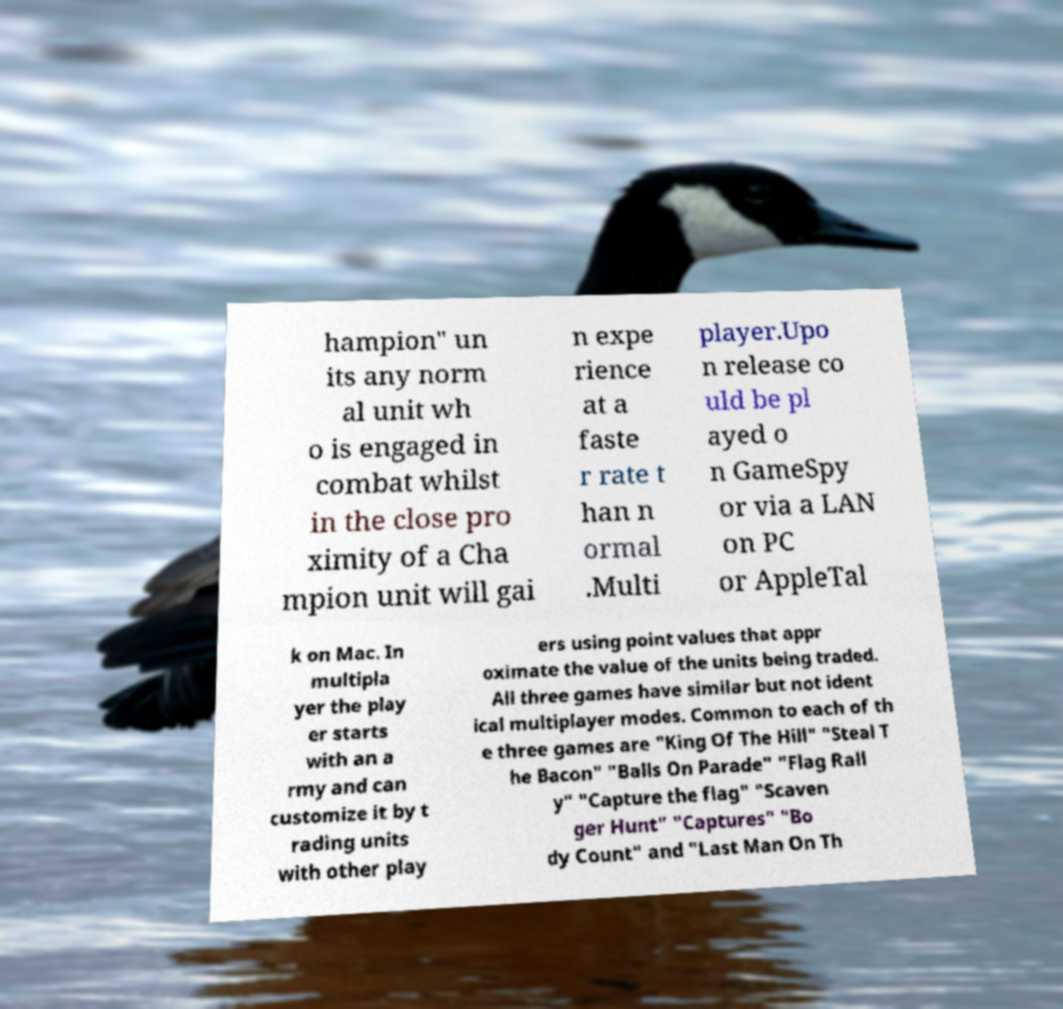There's text embedded in this image that I need extracted. Can you transcribe it verbatim? hampion" un its any norm al unit wh o is engaged in combat whilst in the close pro ximity of a Cha mpion unit will gai n expe rience at a faste r rate t han n ormal .Multi player.Upo n release co uld be pl ayed o n GameSpy or via a LAN on PC or AppleTal k on Mac. In multipla yer the play er starts with an a rmy and can customize it by t rading units with other play ers using point values that appr oximate the value of the units being traded. All three games have similar but not ident ical multiplayer modes. Common to each of th e three games are "King Of The Hill" "Steal T he Bacon" "Balls On Parade" "Flag Rall y" "Capture the flag" "Scaven ger Hunt" "Captures" "Bo dy Count" and "Last Man On Th 